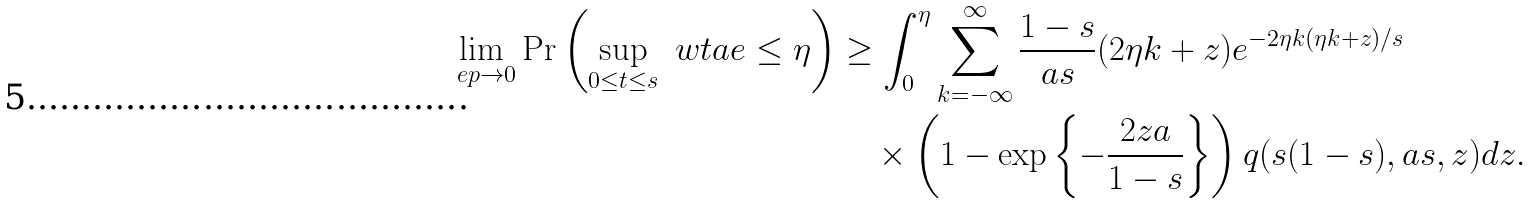Convert formula to latex. <formula><loc_0><loc_0><loc_500><loc_500>\lim _ { \ e p \rightarrow 0 } \Pr \left ( \sup _ { 0 \leq t \leq s } \ w t a e \leq \eta \right ) & \geq \int _ { 0 } ^ { \eta } \sum _ { k = - \infty } ^ { \infty } \frac { 1 - s } { a s } ( 2 \eta k + z ) e ^ { - 2 \eta k ( \eta k + z ) / s } \\ & \quad \times \left ( 1 - \exp \left \{ - \frac { 2 z a } { 1 - s } \right \} \right ) q ( s ( 1 - s ) , a s , z ) d z .</formula> 